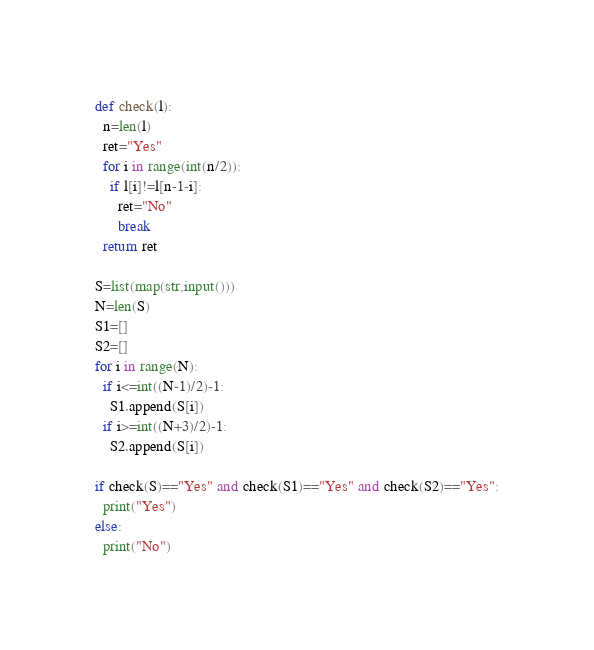<code> <loc_0><loc_0><loc_500><loc_500><_Python_>def check(l):
  n=len(l)
  ret="Yes"
  for i in range(int(n/2)):
    if l[i]!=l[n-1-i]:
      ret="No"
      break
  return ret

S=list(map(str,input()))
N=len(S)
S1=[]
S2=[]
for i in range(N):
  if i<=int((N-1)/2)-1:
    S1.append(S[i])
  if i>=int((N+3)/2)-1:
    S2.append(S[i])

if check(S)=="Yes" and check(S1)=="Yes" and check(S2)=="Yes":
  print("Yes")
else:
  print("No")</code> 